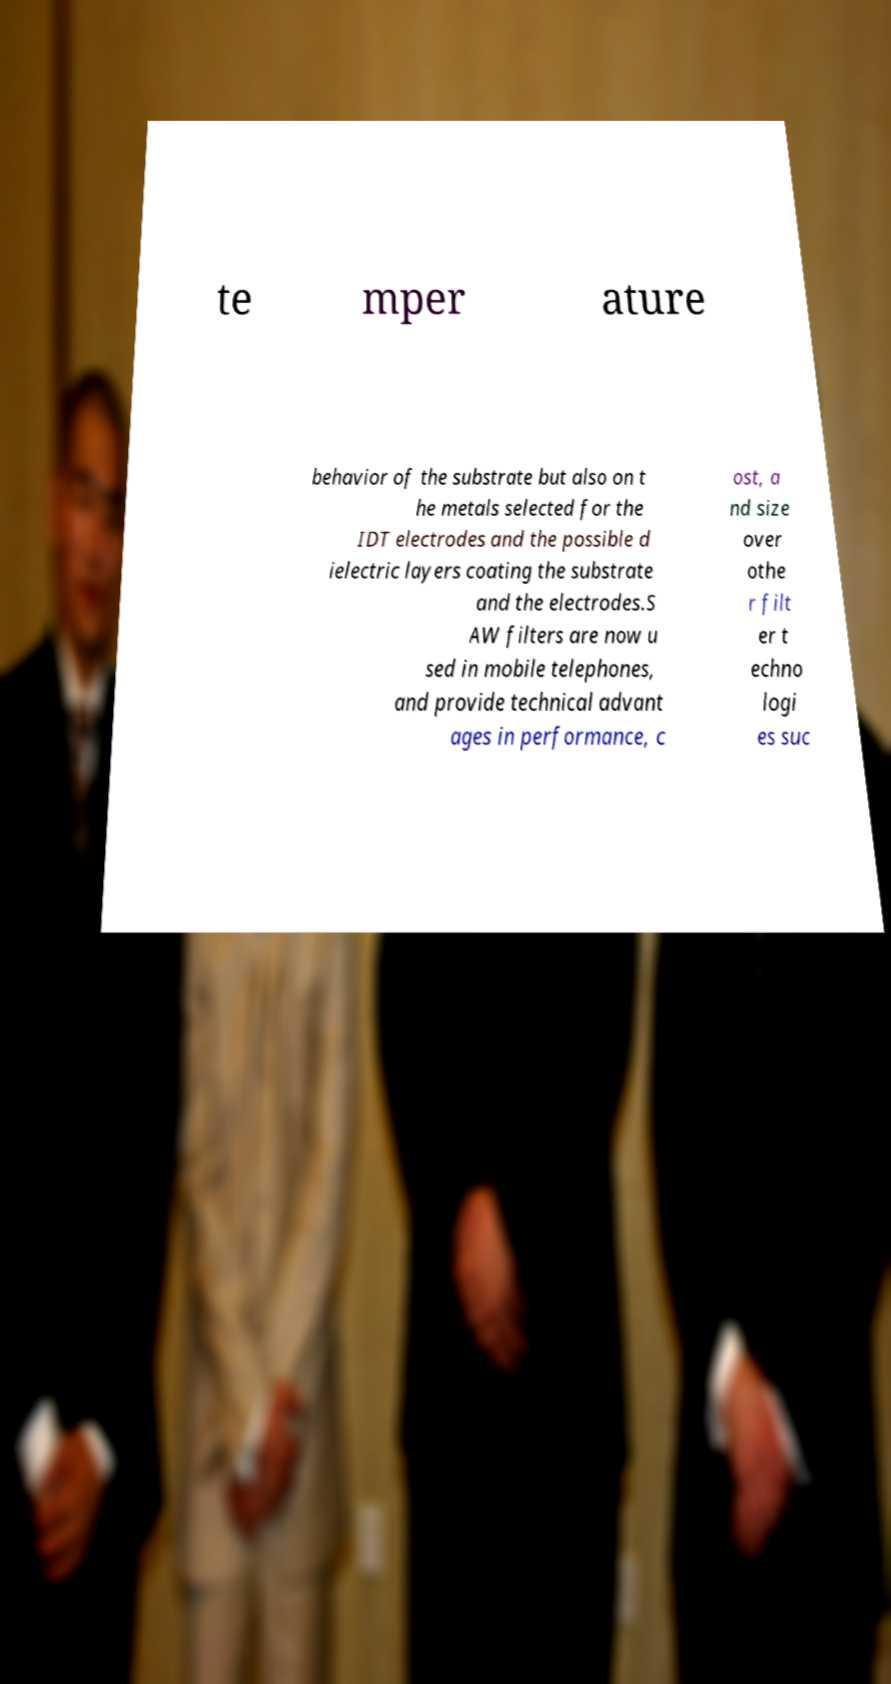Could you assist in decoding the text presented in this image and type it out clearly? te mper ature behavior of the substrate but also on t he metals selected for the IDT electrodes and the possible d ielectric layers coating the substrate and the electrodes.S AW filters are now u sed in mobile telephones, and provide technical advant ages in performance, c ost, a nd size over othe r filt er t echno logi es suc 